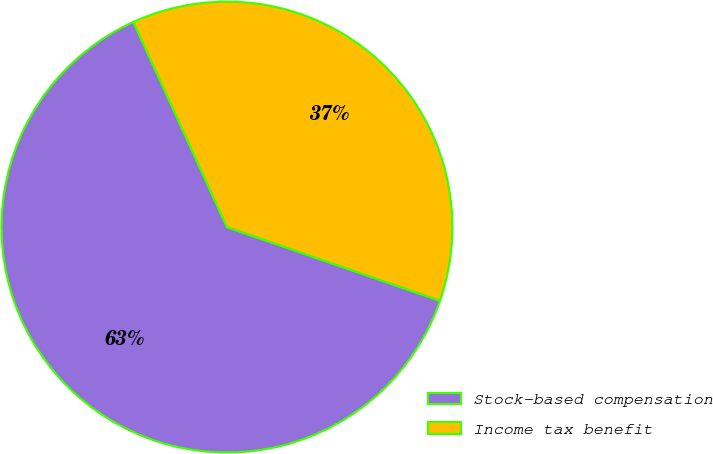Convert chart to OTSL. <chart><loc_0><loc_0><loc_500><loc_500><pie_chart><fcel>Stock-based compensation<fcel>Income tax benefit<nl><fcel>62.89%<fcel>37.11%<nl></chart> 